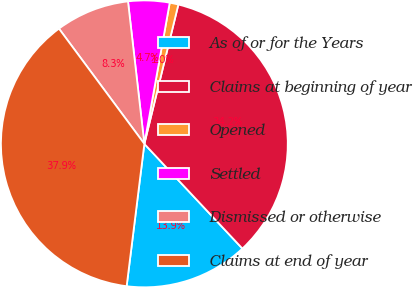Convert chart to OTSL. <chart><loc_0><loc_0><loc_500><loc_500><pie_chart><fcel>As of or for the Years<fcel>Claims at beginning of year<fcel>Opened<fcel>Settled<fcel>Dismissed or otherwise<fcel>Claims at end of year<nl><fcel>13.95%<fcel>34.21%<fcel>0.98%<fcel>4.65%<fcel>8.33%<fcel>37.88%<nl></chart> 